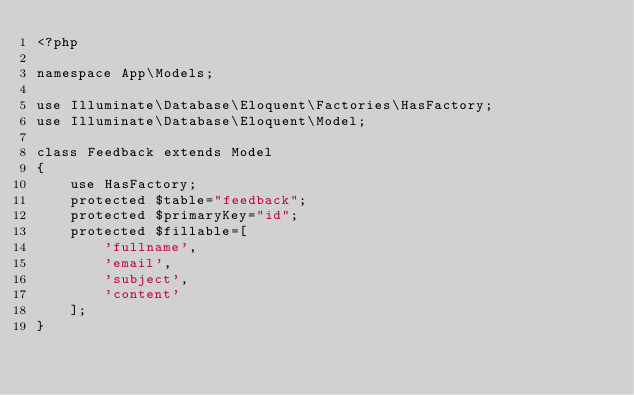<code> <loc_0><loc_0><loc_500><loc_500><_PHP_><?php

namespace App\Models;

use Illuminate\Database\Eloquent\Factories\HasFactory;
use Illuminate\Database\Eloquent\Model;

class Feedback extends Model
{
    use HasFactory;
    protected $table="feedback";
    protected $primaryKey="id";
    protected $fillable=[
        'fullname',
        'email',
        'subject',
        'content'
    ];
}
</code> 